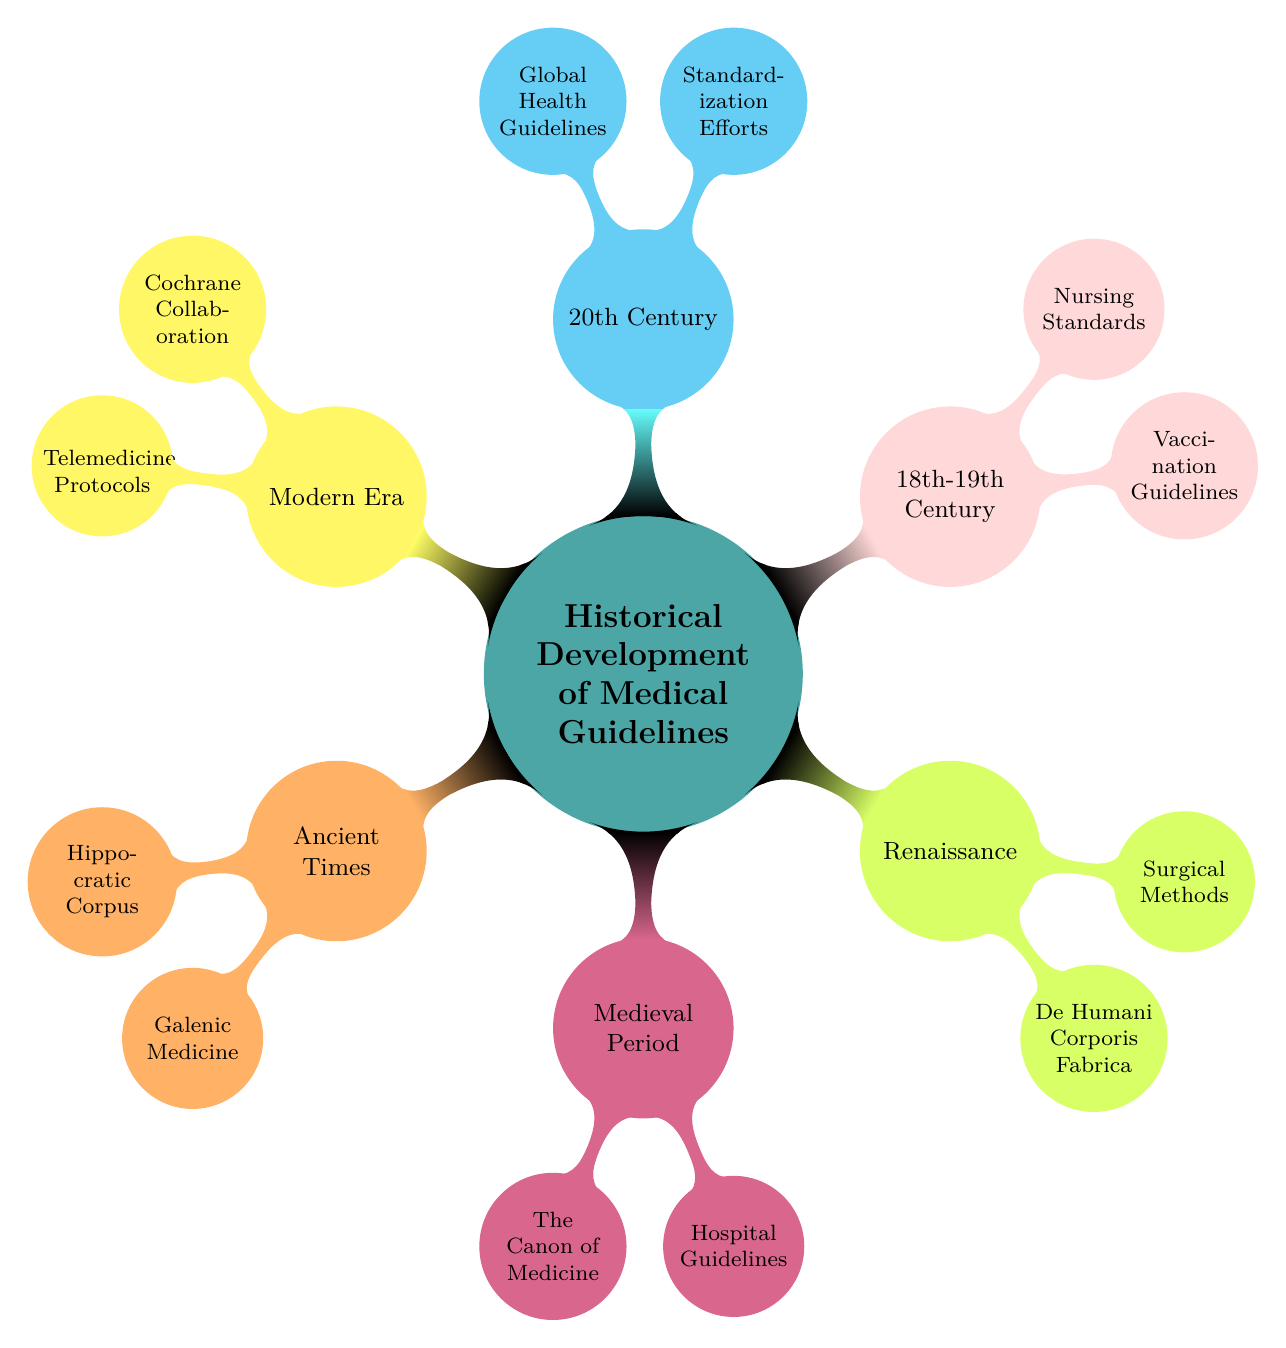What are the two main topics in the Ancient Times section? The diagram indicates that the Ancient Times section includes two nodes: Hippocratic Corpus and Galenic Medicine. These are the specific contributions mentioned under Ancient Times.
Answer: Hippocratic Corpus, Galenic Medicine Which medical guidelines were established during the 18th-19th Century? The diagram specifies two key contributions during the 18th-19th Century: Vaccination Guidelines and Nursing Standards. These are the primary guidelines recognized in that era.
Answer: Vaccination Guidelines, Nursing Standards How many major periods are highlighted in the diagram? The diagram reveals six major periods in the historical development of medical guidelines: Ancient Times, Medieval Period, Renaissance, 18th-19th Century, 20th Century, and Modern Era.
Answer: 6 Which figure is associated with the Hospital Guidelines? From the Medieval Period section, the diagram connects Hospital Guidelines to the contribution made by Monastic Hospitals. Thus, Monastic Hospitals is the figure associated with this guideline.
Answer: Monastic Hospitals What was a key focus of the 20th Century in medical guidelines? The diagram indicates that in the 20th Century, the focus was on Standardization Efforts and Global Health Guidelines which involved systematic approaches to improve health care.
Answer: Standardization Efforts, Global Health Guidelines Which era introduced Evidence-Based Medicine? The diagram shows that the Modern Era is where Evidence-Based Medicine, exemplified by the Cochrane Collaboration, was introduced and developed for better clinical practices.
Answer: Modern Era 